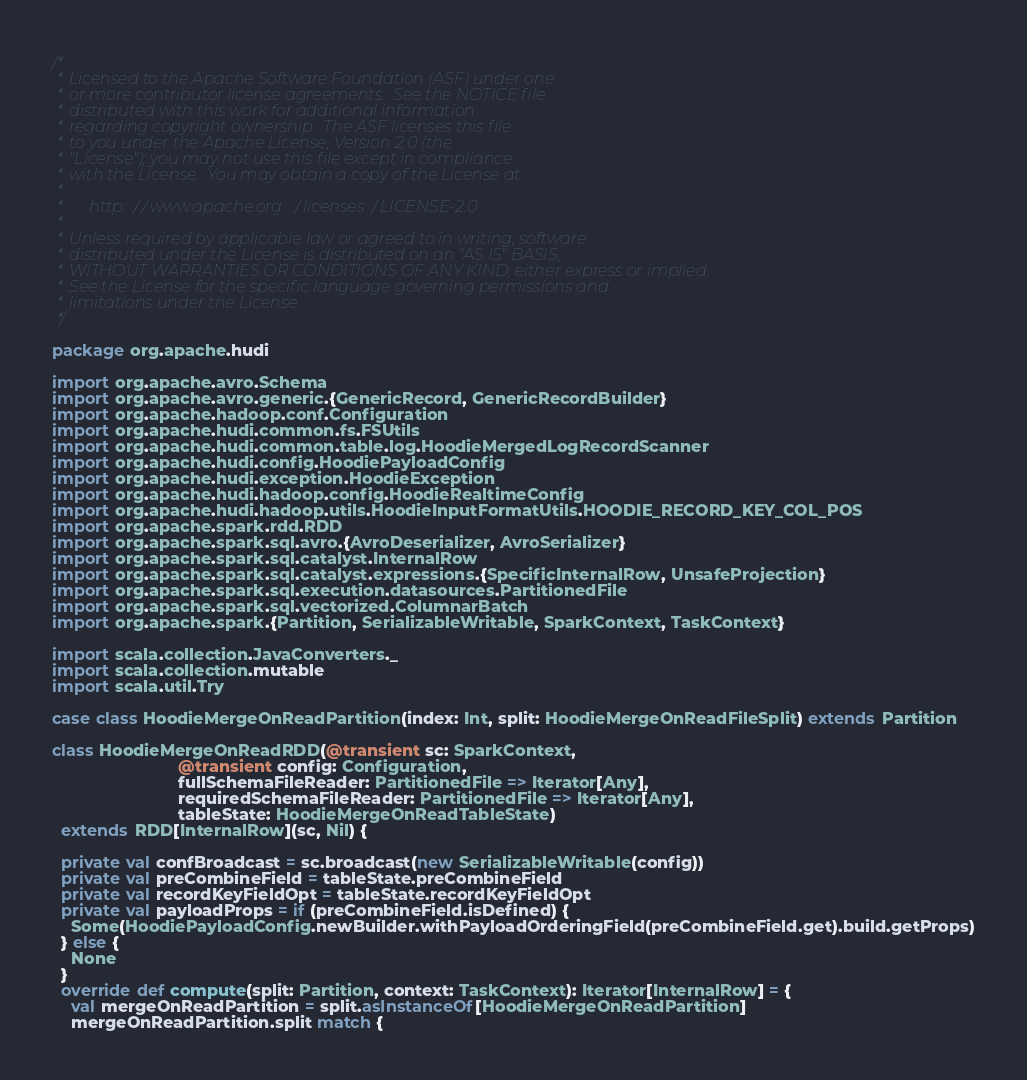Convert code to text. <code><loc_0><loc_0><loc_500><loc_500><_Scala_>/*
 * Licensed to the Apache Software Foundation (ASF) under one
 * or more contributor license agreements.  See the NOTICE file
 * distributed with this work for additional information
 * regarding copyright ownership.  The ASF licenses this file
 * to you under the Apache License, Version 2.0 (the
 * "License"); you may not use this file except in compliance
 * with the License.  You may obtain a copy of the License at
 *
 *      http://www.apache.org/licenses/LICENSE-2.0
 *
 * Unless required by applicable law or agreed to in writing, software
 * distributed under the License is distributed on an "AS IS" BASIS,
 * WITHOUT WARRANTIES OR CONDITIONS OF ANY KIND, either express or implied.
 * See the License for the specific language governing permissions and
 * limitations under the License.
 */

package org.apache.hudi

import org.apache.avro.Schema
import org.apache.avro.generic.{GenericRecord, GenericRecordBuilder}
import org.apache.hadoop.conf.Configuration
import org.apache.hudi.common.fs.FSUtils
import org.apache.hudi.common.table.log.HoodieMergedLogRecordScanner
import org.apache.hudi.config.HoodiePayloadConfig
import org.apache.hudi.exception.HoodieException
import org.apache.hudi.hadoop.config.HoodieRealtimeConfig
import org.apache.hudi.hadoop.utils.HoodieInputFormatUtils.HOODIE_RECORD_KEY_COL_POS
import org.apache.spark.rdd.RDD
import org.apache.spark.sql.avro.{AvroDeserializer, AvroSerializer}
import org.apache.spark.sql.catalyst.InternalRow
import org.apache.spark.sql.catalyst.expressions.{SpecificInternalRow, UnsafeProjection}
import org.apache.spark.sql.execution.datasources.PartitionedFile
import org.apache.spark.sql.vectorized.ColumnarBatch
import org.apache.spark.{Partition, SerializableWritable, SparkContext, TaskContext}

import scala.collection.JavaConverters._
import scala.collection.mutable
import scala.util.Try

case class HoodieMergeOnReadPartition(index: Int, split: HoodieMergeOnReadFileSplit) extends Partition

class HoodieMergeOnReadRDD(@transient sc: SparkContext,
                           @transient config: Configuration,
                           fullSchemaFileReader: PartitionedFile => Iterator[Any],
                           requiredSchemaFileReader: PartitionedFile => Iterator[Any],
                           tableState: HoodieMergeOnReadTableState)
  extends RDD[InternalRow](sc, Nil) {

  private val confBroadcast = sc.broadcast(new SerializableWritable(config))
  private val preCombineField = tableState.preCombineField
  private val recordKeyFieldOpt = tableState.recordKeyFieldOpt
  private val payloadProps = if (preCombineField.isDefined) {
    Some(HoodiePayloadConfig.newBuilder.withPayloadOrderingField(preCombineField.get).build.getProps)
  } else {
    None
  }
  override def compute(split: Partition, context: TaskContext): Iterator[InternalRow] = {
    val mergeOnReadPartition = split.asInstanceOf[HoodieMergeOnReadPartition]
    mergeOnReadPartition.split match {</code> 